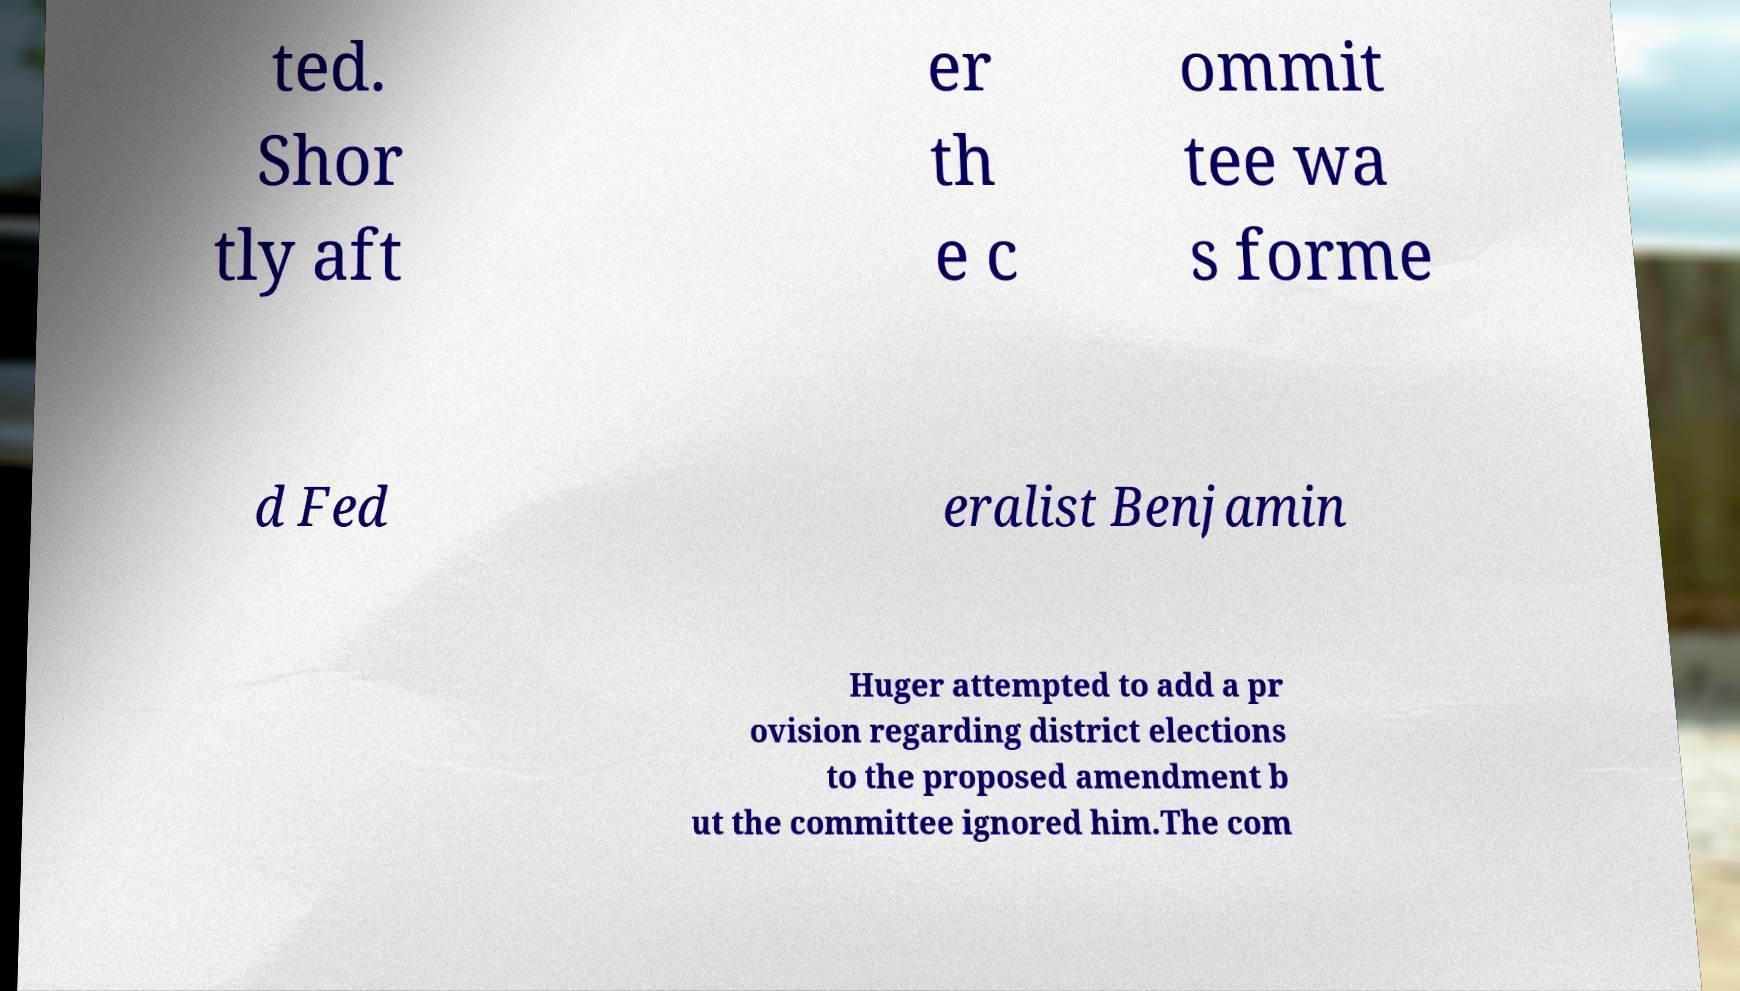Could you extract and type out the text from this image? ted. Shor tly aft er th e c ommit tee wa s forme d Fed eralist Benjamin Huger attempted to add a pr ovision regarding district elections to the proposed amendment b ut the committee ignored him.The com 